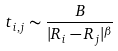Convert formula to latex. <formula><loc_0><loc_0><loc_500><loc_500>t _ { i , j } \sim \frac { B } { | { R } _ { i } - { R } _ { j } | ^ { \beta } }</formula> 